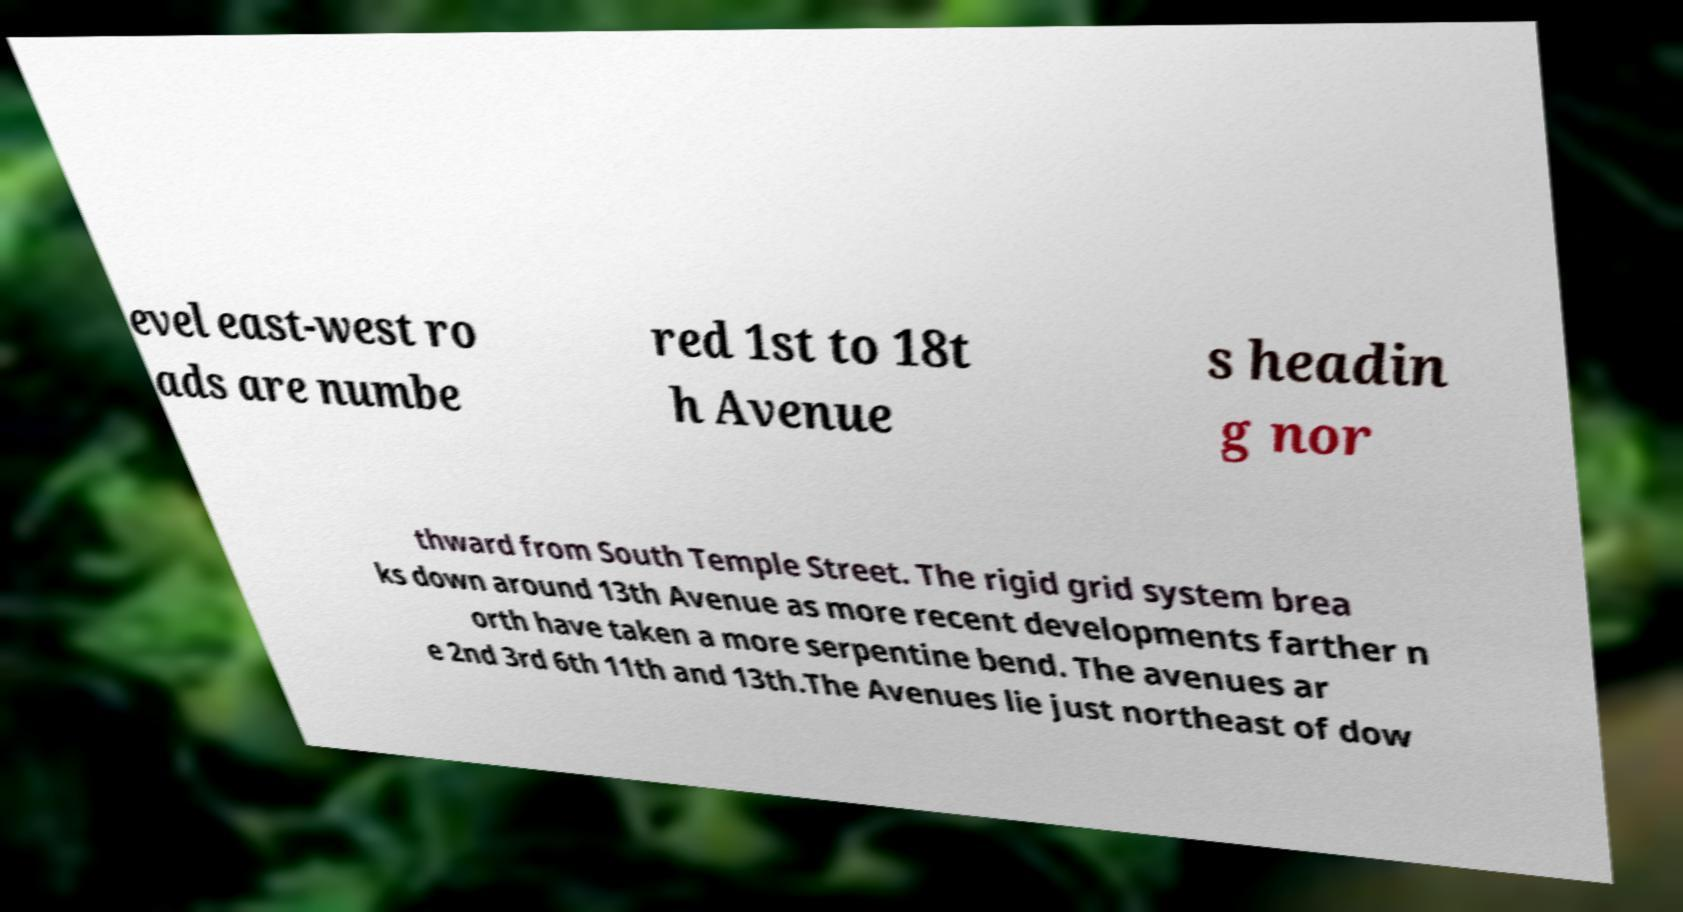Please identify and transcribe the text found in this image. evel east-west ro ads are numbe red 1st to 18t h Avenue s headin g nor thward from South Temple Street. The rigid grid system brea ks down around 13th Avenue as more recent developments farther n orth have taken a more serpentine bend. The avenues ar e 2nd 3rd 6th 11th and 13th.The Avenues lie just northeast of dow 